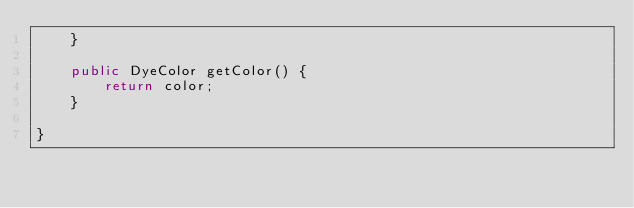Convert code to text. <code><loc_0><loc_0><loc_500><loc_500><_Java_>	}
	
	public DyeColor getColor() {
		return color;
	}

}
</code> 